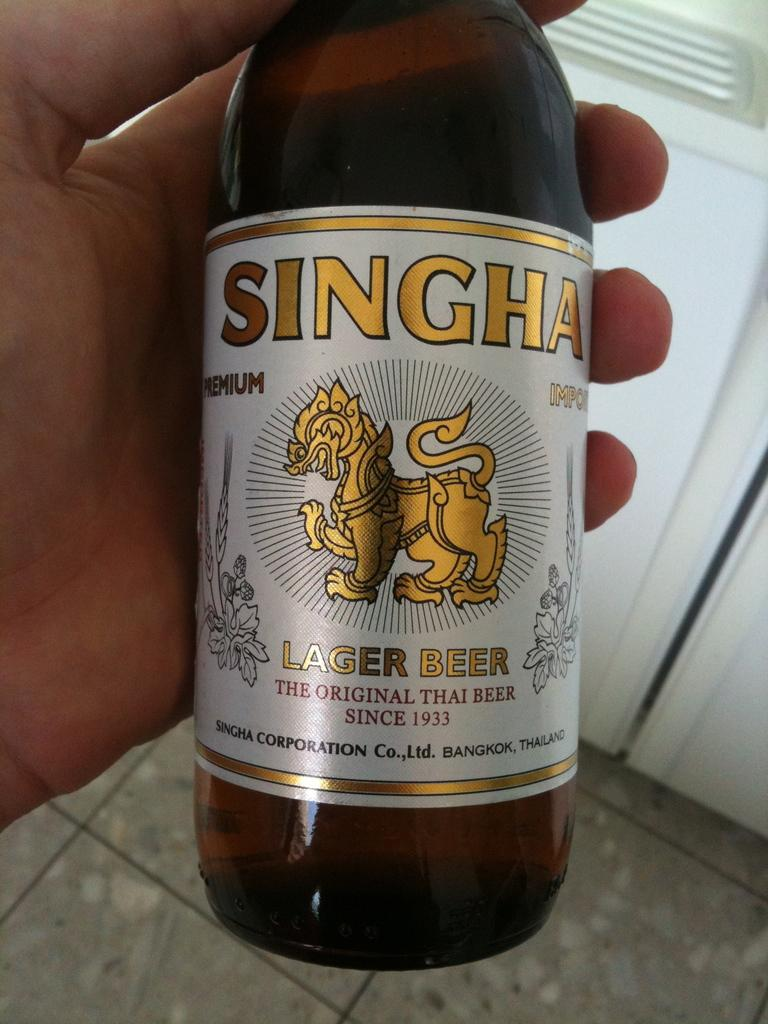<image>
Summarize the visual content of the image. A hand holds a bottle of Singha lager beer. 